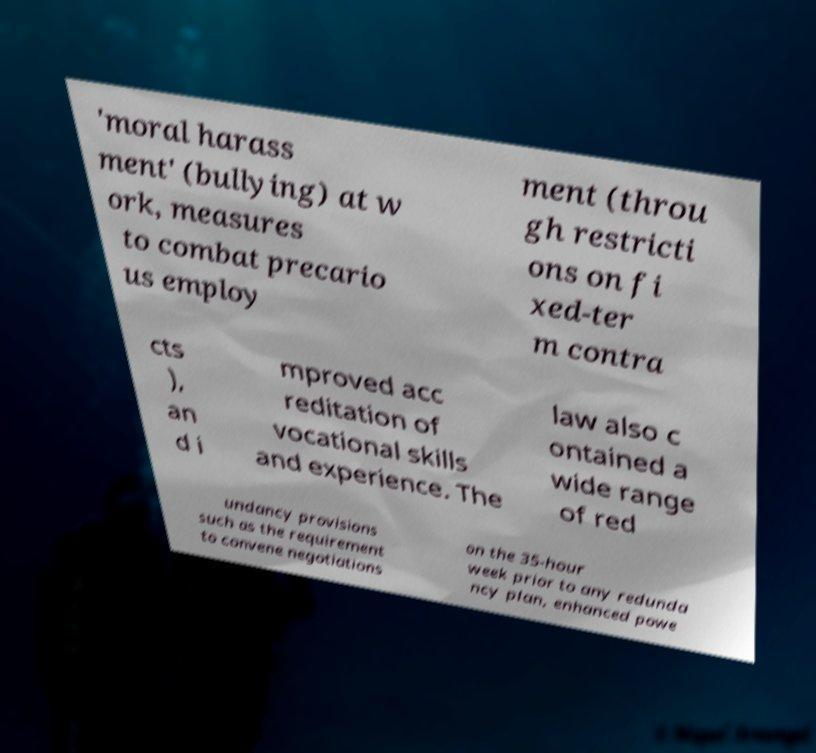For documentation purposes, I need the text within this image transcribed. Could you provide that? 'moral harass ment' (bullying) at w ork, measures to combat precario us employ ment (throu gh restricti ons on fi xed-ter m contra cts ), an d i mproved acc reditation of vocational skills and experience. The law also c ontained a wide range of red undancy provisions such as the requirement to convene negotiations on the 35-hour week prior to any redunda ncy plan, enhanced powe 